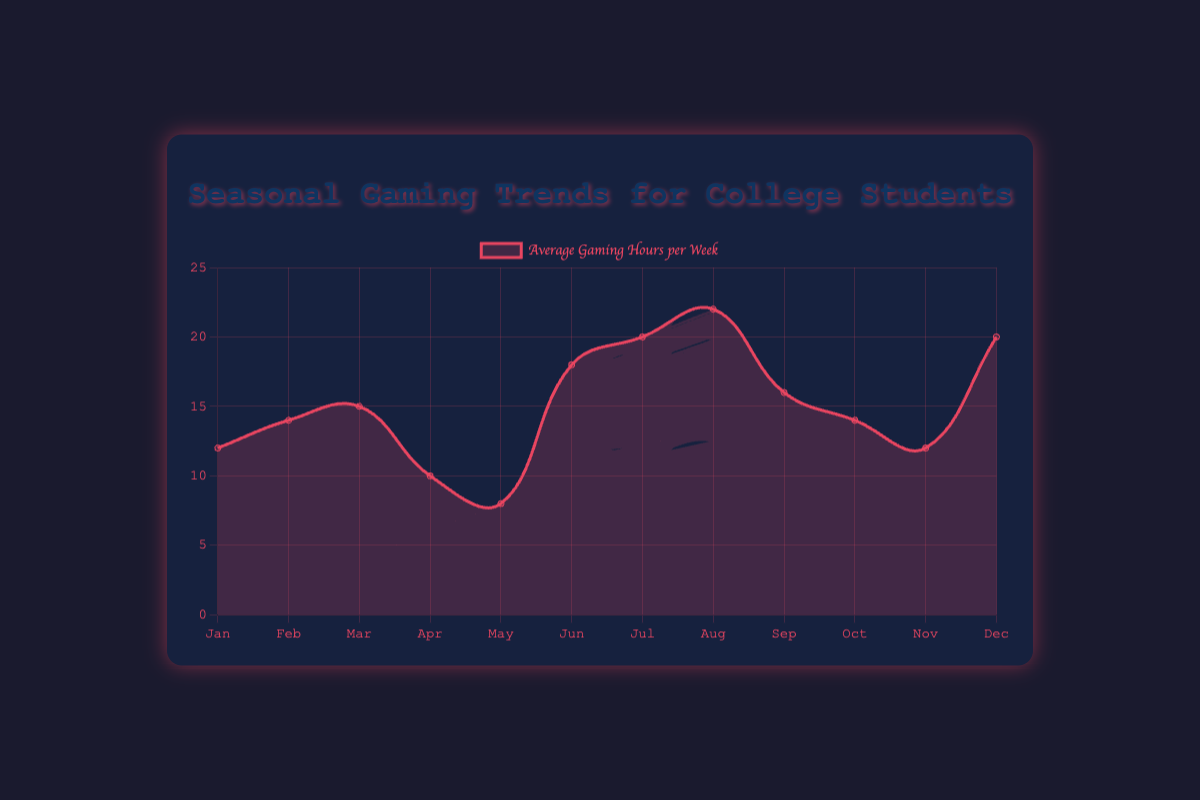Which month shows the lowest average gaming hours per week? Observing the figure, the lowest point on the curve represents the lowest average gaming hours per week. This occurs in May where the average is 8 hours per week.
Answer: May Which months have the highest study pressure? According to the tooltip information from the data scooped in the figure, May and November have the highest study pressure, labeled as "Very High".
Answer: May, November What's the difference in average gaming hours per week between August and January? From the figure, August shows an average of 22 hours per week while January shows 12 hours per week. The difference is 22 - 12 = 10 hours.
Answer: 10 hours How do average gaming hours in July compare to those in December? From the figure, both July and December show the same average gaming hours per week, which is 20 hours.
Answer: They are equal What is the average of gaming hours per week from June to August? The monthly average gaming hours, from the figure, are June (18), July (20), and August (22). The average is (18 + 20 + 22) / 3 = 20 hours.
Answer: 20 hours What is the trend in average gaming hours per week from January to March? Observing the figure, there is a consistent increase in the average gaming hours per week from January (12 hours) through February (14 hours) to March (15 hours).
Answer: Increasing In which month is the average gaming hours per week close to the median value? Sorting the average gaming hours: 8, 10, 12, 12, 14, 14, 15, 16, 18, 20, 20, 22; the median value is (14+15)/2 = 14.5. October (14) and September (16) are close to this median.
Answer: October or September Which months show a decrease in average gaming hours per week compared to the previous month? Observing the figure, April shows a decrease (from 15 to 10), May (from 10 to 8), and September (from 22 to 16).
Answer: April, May, September 